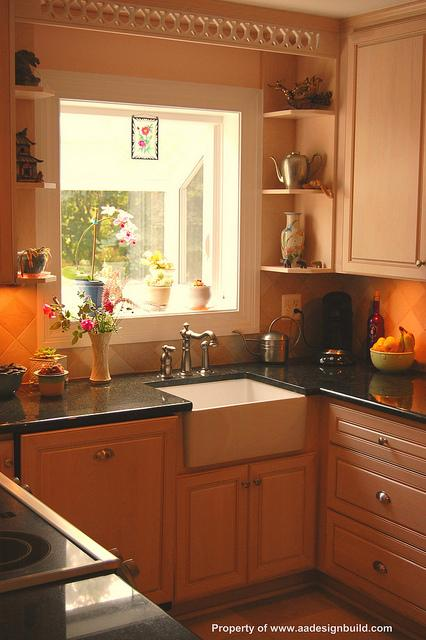What is the type of stove cooktop called? electric 